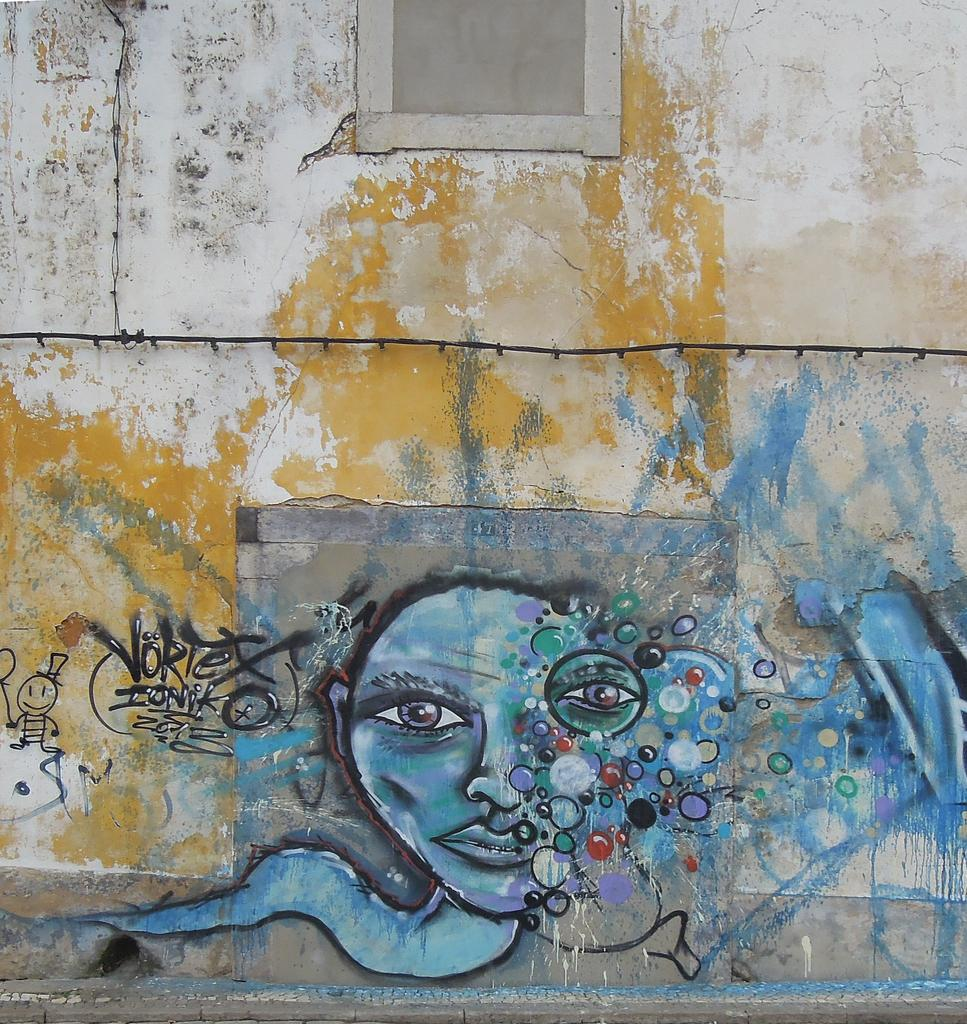What is hanging on the wall in the image? There is a painting on the wall in the image. Can you describe any other objects present in the image? Unfortunately, the provided facts only mention that there are objects present in the image, but no specific details are given. How many umbrellas are being used by the machine in the image? There is no machine or umbrella present in the image. 